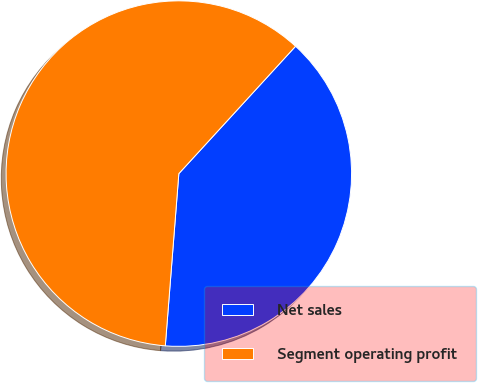Convert chart. <chart><loc_0><loc_0><loc_500><loc_500><pie_chart><fcel>Net sales<fcel>Segment operating profit<nl><fcel>39.44%<fcel>60.56%<nl></chart> 